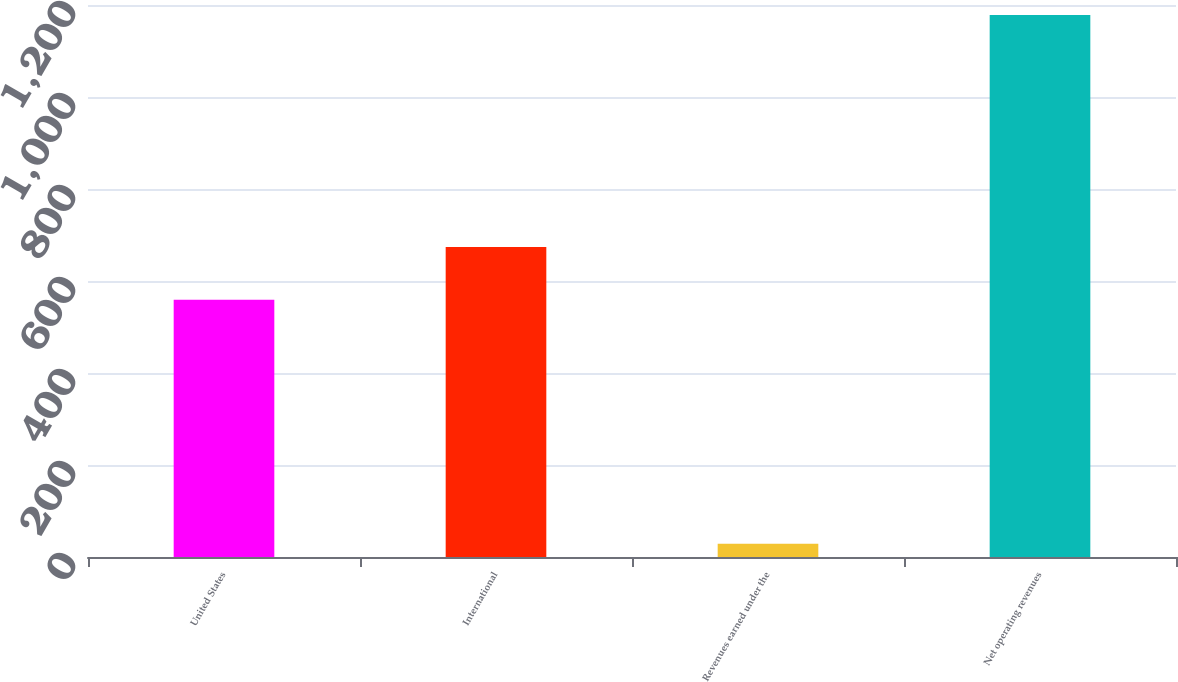Convert chart. <chart><loc_0><loc_0><loc_500><loc_500><bar_chart><fcel>United States<fcel>International<fcel>Revenues earned under the<fcel>Net operating revenues<nl><fcel>559<fcel>673.9<fcel>29<fcel>1178<nl></chart> 